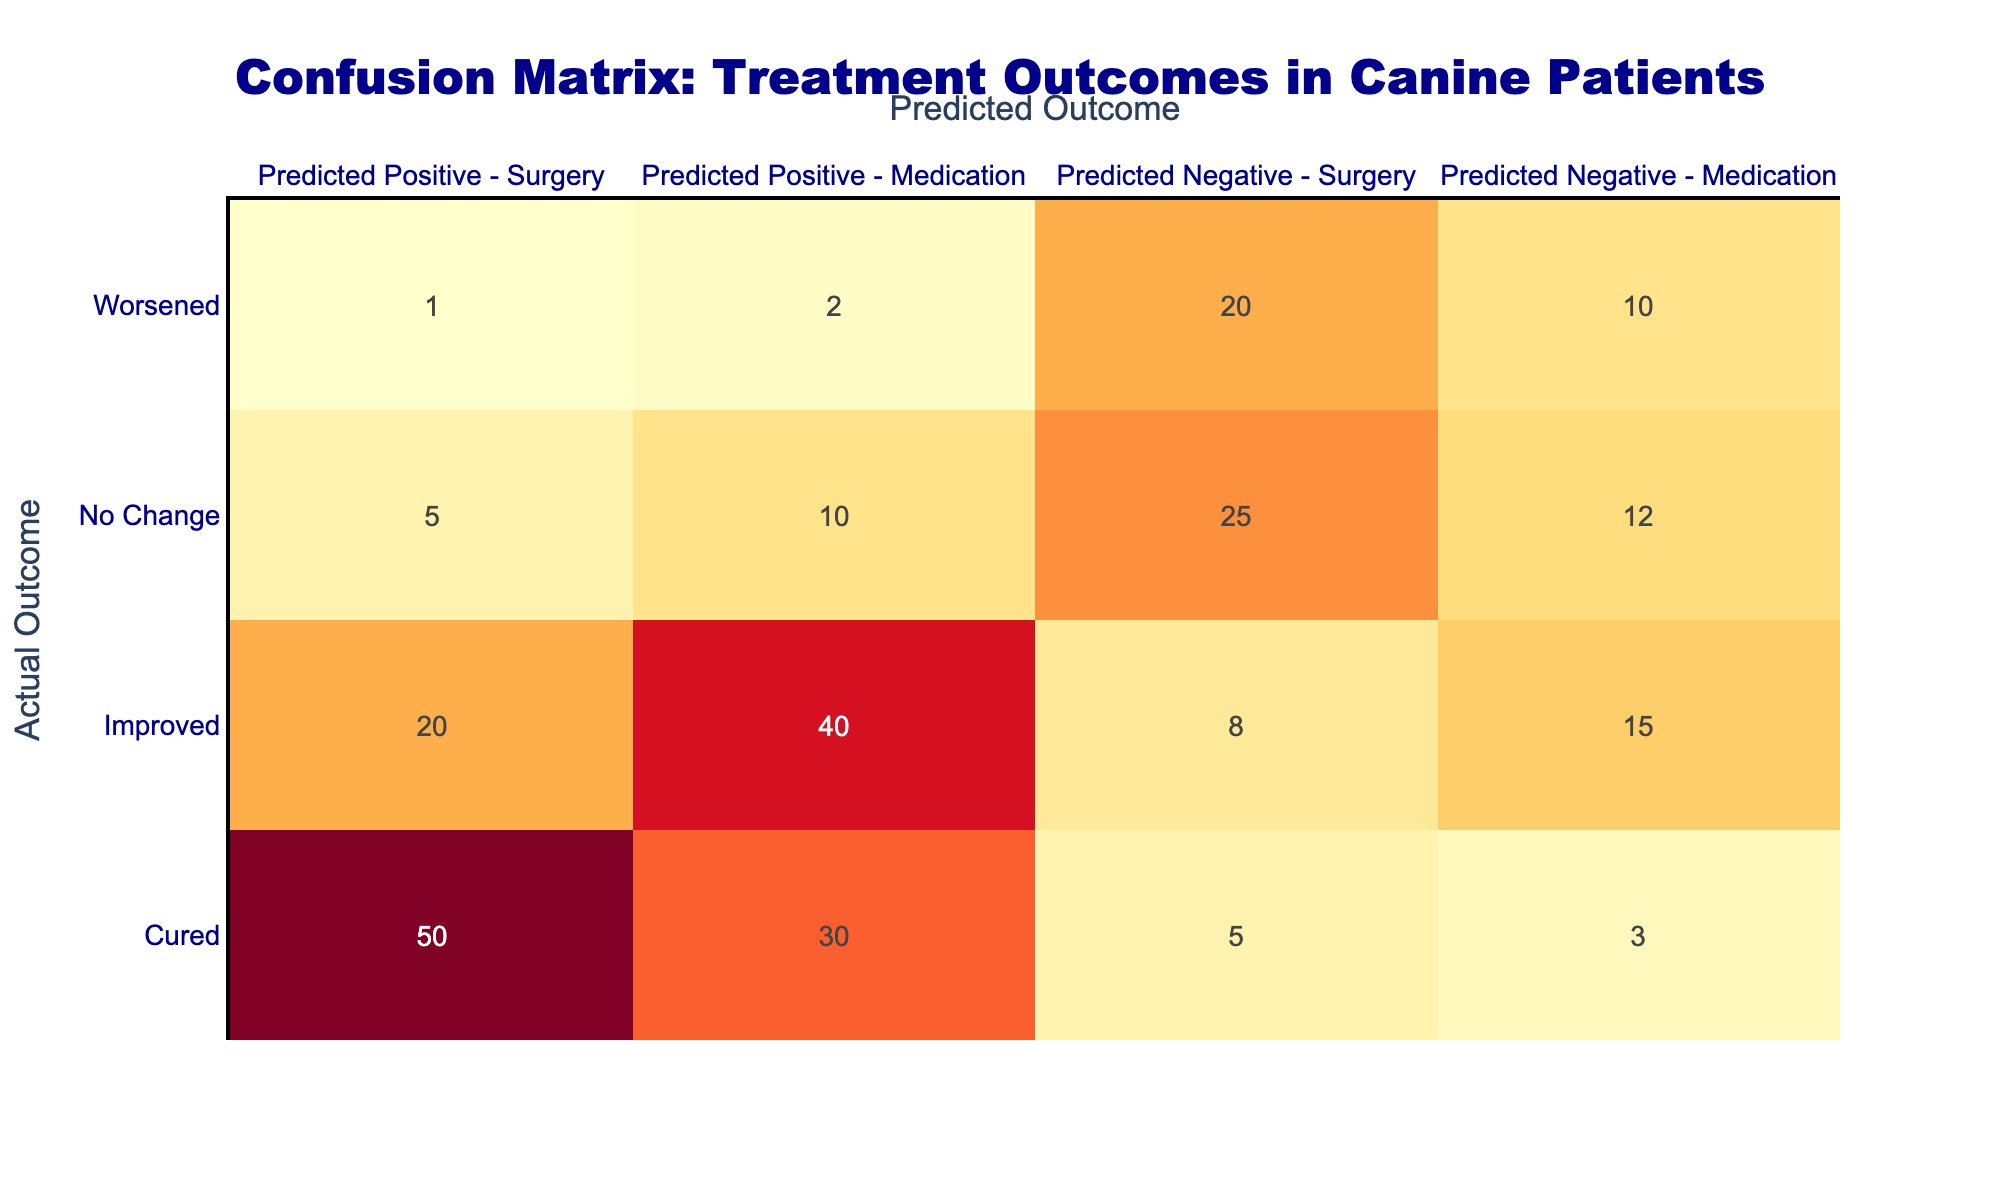What is the total number of canine patients that were cured with the surgery treatment? The table shows the row for "Cured" under the "Predicted Positive - Surgery" column, which indicates 50 patients. Thus, the total number of patients cured with surgery is exactly that number.
Answer: 50 How many patients experienced no change when treated with medication? The table shows the row for "No Change" under the "Predicted Negative - Medication" column, where it indicates 12 patients. Therefore, the number of patients who experienced no change with medication treatment is 12.
Answer: 12 What is the total count of patients who worsened regardless of the treatment method? We need to look at the row for "Worsened," which has values for both treatment methods. The count is 1 (surgery) + 2 (medication) + 20 (surgery) + 10 (medication) = 33. Therefore, the total count of patients that worsened is 33.
Answer: 33 Is it true that more patients improved with medication than with surgery? From the table, we can see that the number of patients who improved with medication is 40, while those who improved with surgery is 20. This confirms that more patients improved with medication than with surgery.
Answer: Yes What is the difference in the number of patients cured by surgery and those cured by medication? From the table, the number of patients cured by surgery is 50, and those cured by medication is 30. The difference is calculated as 50 - 30 = 20. Therefore, the difference in the number of patients cured by surgery compared to medication is 20.
Answer: 20 How many patients were classified as "Worsened" when treated with surgery? The table shows that under the "Worsened" category, there are 1 patient under "Predicted Positive - Surgery" and 20 patients under "Predicted Negative - Surgery." Adding these values gives 21 patients who worsened with surgery.
Answer: 21 What percentage of patients that were cured were treated with medication? To calculate this, we first find the total cured patients: 50 (surgery) + 30 (medication) = 80. Then, we calculate the percentage that were cured with medication: (30/80) * 100 = 37.5%. Thus, 37.5% of the cured patients were treated with medication.
Answer: 37.5% Which treatment resulted in a higher number of patients showing no change? We compare the "No Change" row for both treatments: 25 patients with surgery versus 12 with medication indicates that the surgery treatment resulted in a higher number of patients showing no change.
Answer: Surgery 